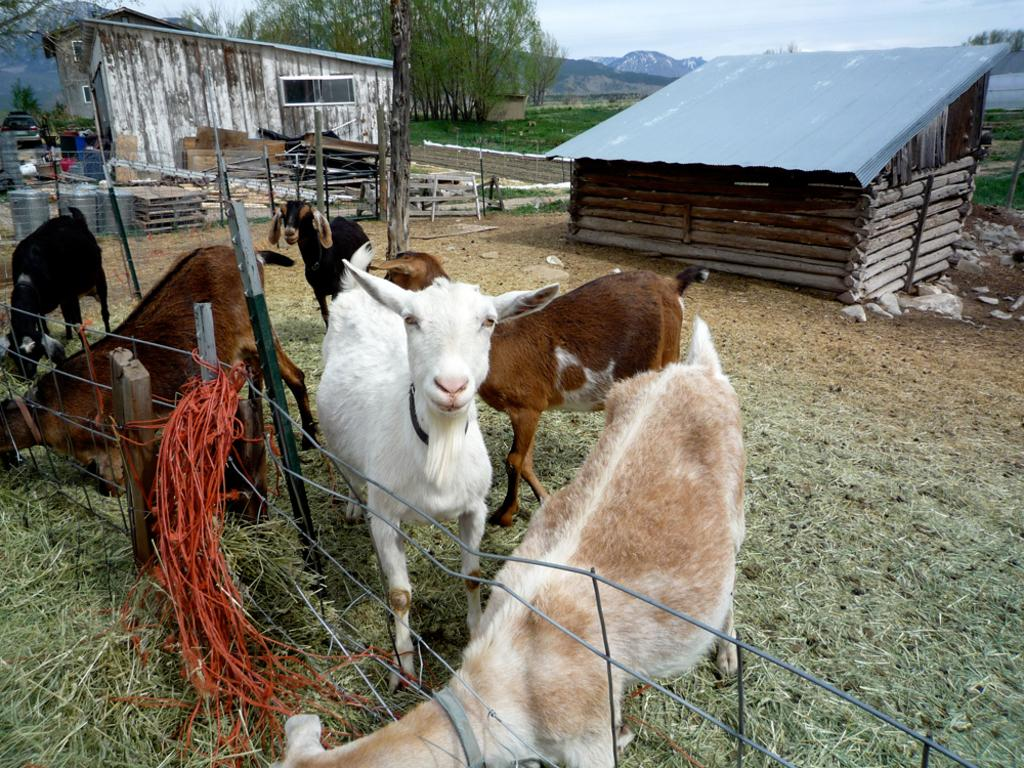What animals can be seen in the image? There are goats in the image. What are the goats doing in the image? The goats are grazing grass in the image. Where are the goats located? The goats are inside a fenced area. What structures can be seen in the background of the image? There are 2 wooden shelters in the background. What natural features can be seen in the background of the image? There are mountains and trees visible in the background. What type of chair is dad sitting on in the image? There is no dad or chair present in the image; it features goats grazing grass inside a fenced area. How does the rainstorm affect the goats in the image? There is no rainstorm present in the image; the goats are grazing grass in a clear environment. 